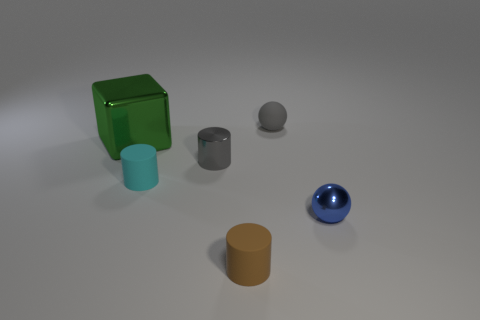How big is the object behind the block?
Provide a succinct answer. Small. Is there a matte block of the same color as the small metal cylinder?
Offer a terse response. No. There is a rubber cylinder that is left of the brown cylinder; is it the same size as the tiny brown matte thing?
Offer a terse response. Yes. The metal cylinder has what color?
Offer a terse response. Gray. There is a sphere behind the cyan rubber object in front of the gray shiny cylinder; what is its color?
Offer a terse response. Gray. Is there a tiny brown cylinder that has the same material as the blue object?
Keep it short and to the point. No. There is a cylinder that is in front of the tiny sphere in front of the green shiny block; what is its material?
Keep it short and to the point. Rubber. What number of small cyan rubber things have the same shape as the blue object?
Your response must be concise. 0. The small gray shiny object is what shape?
Provide a succinct answer. Cylinder. Is the number of shiny blocks less than the number of large metal cylinders?
Give a very brief answer. No. 